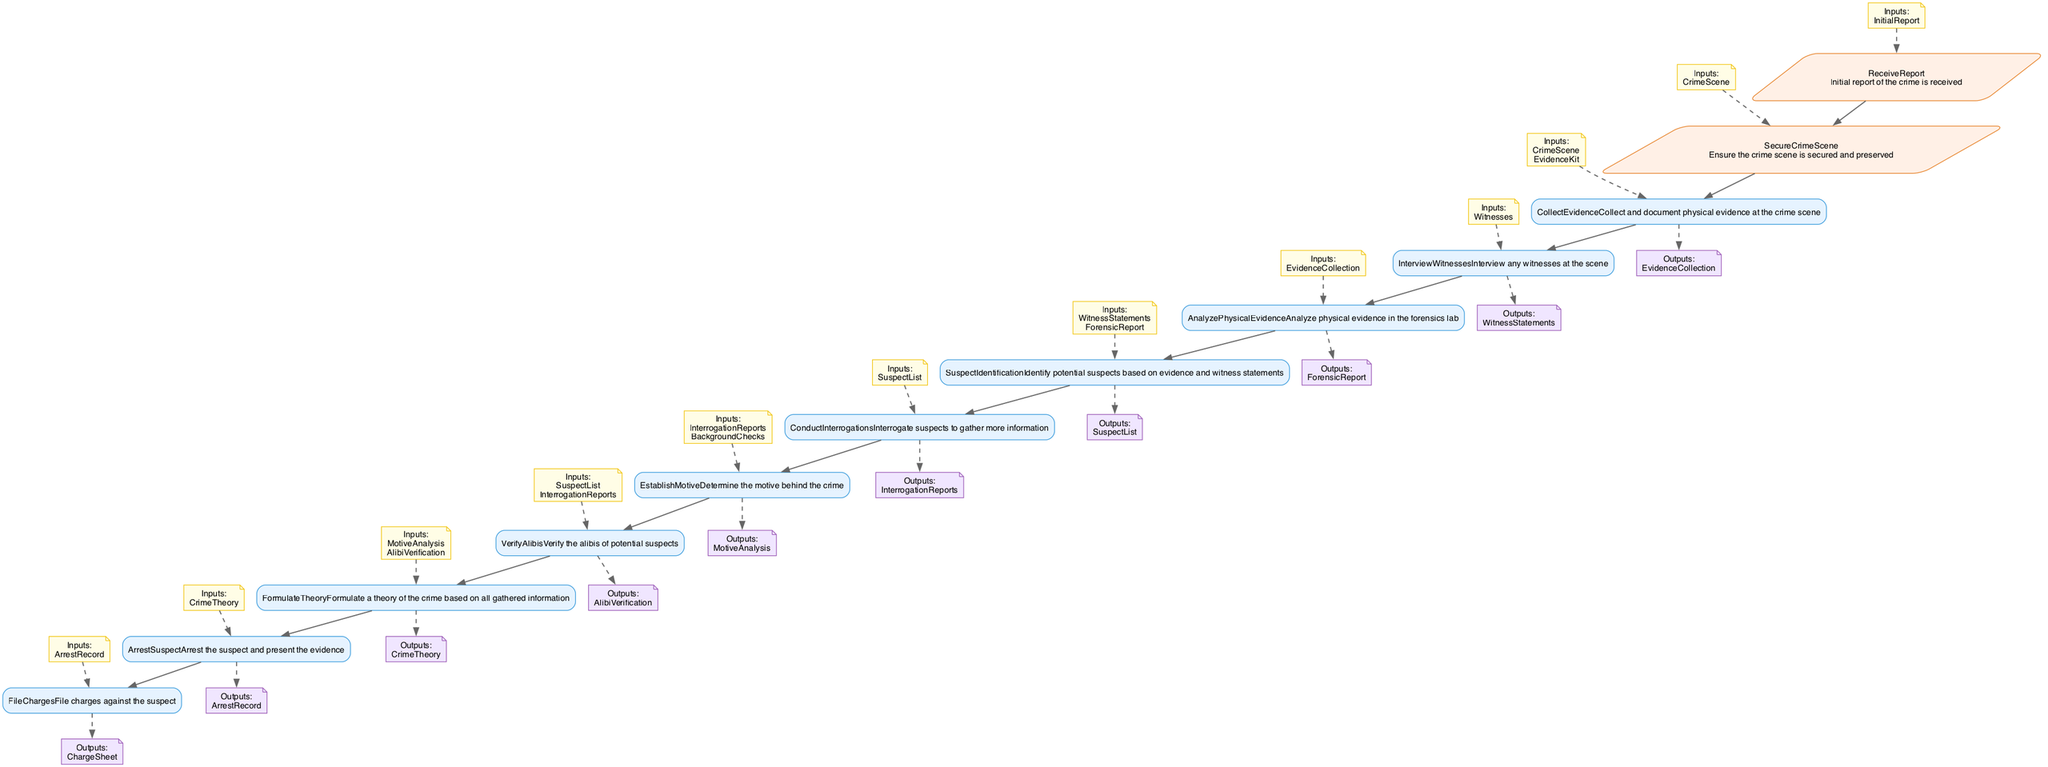What is the first step in the process? The first step in the flowchart is "ReceiveReport," which indicates that the initial report of the crime is received.
Answer: ReceiveReport How many steps are there in total? The flowchart outlines a total of twelve steps, detailing the complete process from report receipt to filing charges.
Answer: Twelve What are the outputs of the "CollectEvidence" step? The output of the "CollectEvidence" step is "EvidenceCollection," which is documented physical evidence collected at the crime scene.
Answer: EvidenceCollection Which step requires both "InterrogationReports" and "BackgroundChecks" as inputs? The step "EstablishMotive" requires "InterrogationReports" and "BackgroundChecks" as inputs to determine the motive behind the crime.
Answer: EstablishMotive What is the output of the "VerifyAlibis" step? The output of the "VerifyAlibis" step is "AlibiVerification," which confirms or denies the alibis of potential suspects.
Answer: AlibiVerification Which step follows "AnalyzePhysicalEvidence"? The step that follows "AnalyzePhysicalEvidence" is "SuspectIdentification," where potential suspects are identified based on the evidence and witness statements.
Answer: SuspectIdentification What type of output does the "ArrestSuspect" step produce? The "ArrestSuspect" step produces an output known as "ArrestRecord," which documents the record of the suspect's arrest.
Answer: ArrestRecord What is the last step in the murder mystery-solving process? The last step in the flowchart is "FileCharges," which involves filing charges against the suspect based on the evidence collected.
Answer: FileCharges How many inputs does the "ConductInterrogations" step require? The "ConductInterrogations" step requires one input, which is the list of suspects determined in the previous steps.
Answer: One 